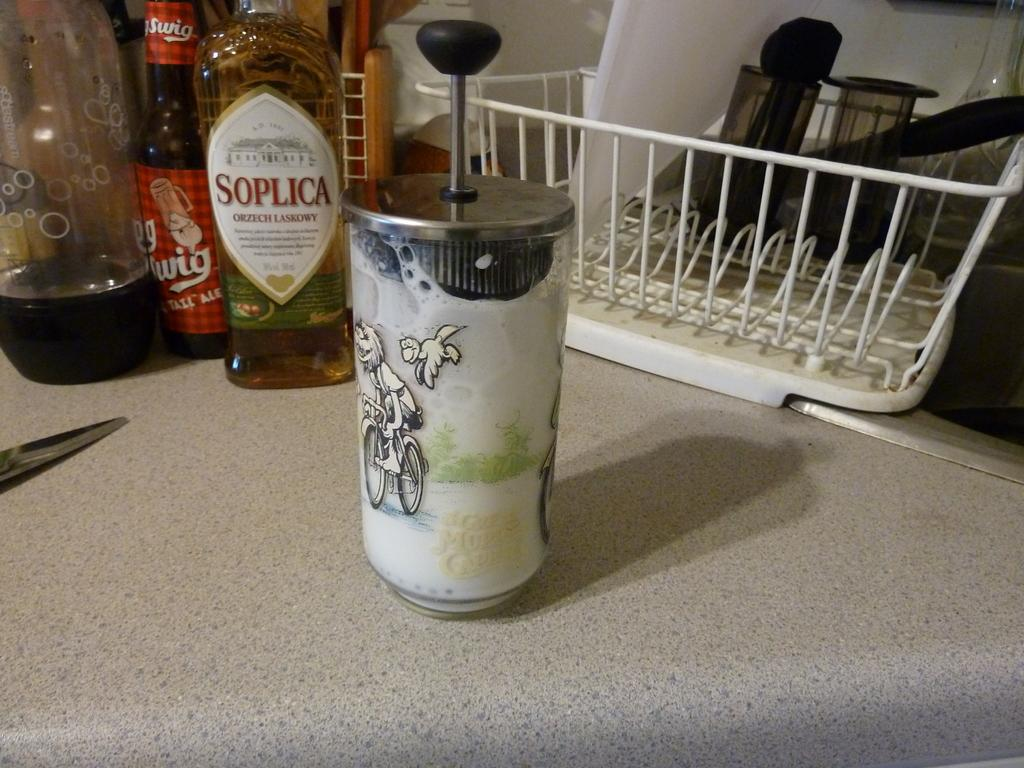<image>
Share a concise interpretation of the image provided. A kitchen with items in bottles such as Soplica 